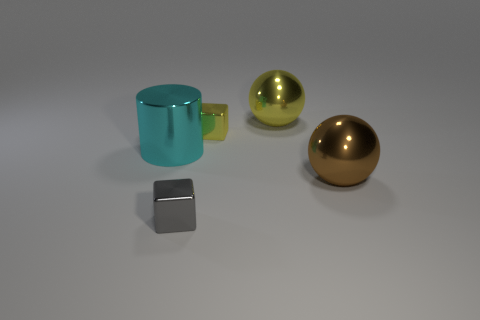How many other big shiny things have the same shape as the large yellow object?
Your answer should be very brief. 1. There is a cyan metal cylinder; does it have the same size as the metal ball to the left of the brown ball?
Your response must be concise. Yes. The object on the left side of the metal block that is in front of the large brown ball is what shape?
Ensure brevity in your answer.  Cylinder. Is the number of large yellow shiny things left of the gray shiny thing less than the number of large cubes?
Ensure brevity in your answer.  No. What number of yellow metal spheres are the same size as the cyan object?
Your answer should be compact. 1. What shape is the object that is in front of the brown metallic ball?
Offer a terse response. Cube. Are there fewer metallic cubes than objects?
Give a very brief answer. Yes. Are there any other things of the same color as the cylinder?
Provide a succinct answer. No. What is the size of the yellow metallic object in front of the yellow shiny ball?
Provide a succinct answer. Small. Are there more big purple rubber cubes than cyan cylinders?
Keep it short and to the point. No. 